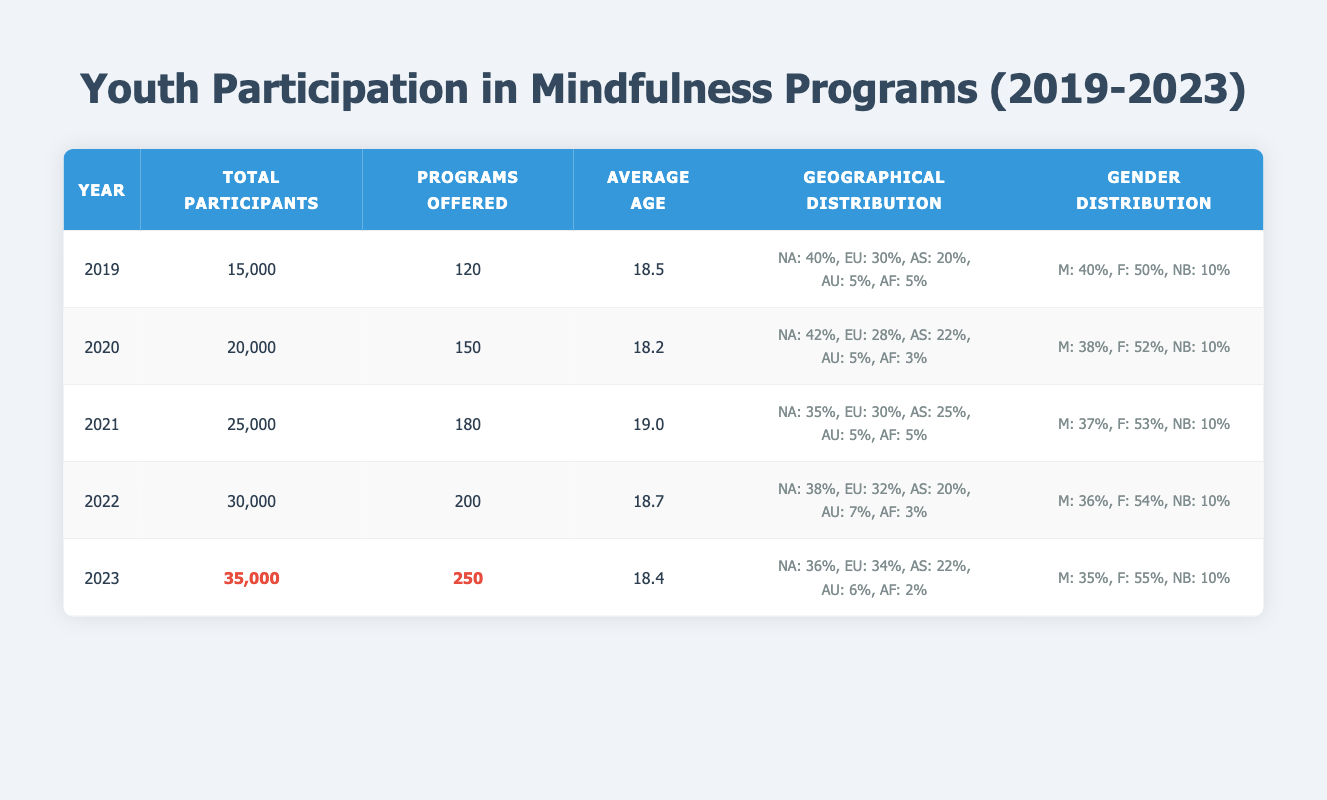What year had the highest number of total participants? By looking at the table, we can see that the total participants increased each year from 2019 to 2023. At a glance, 2023 has the highest value, which is 35000.
Answer: 2023 What was the average age of participants in 2021? The table lists the average age for each year. For the year 2021, the specific figure given is 19.0.
Answer: 19.0 In which year was the geographical distribution of participants from North America the lowest? Checking the North America percentages across the years, 2019 had 40%, following years showed higher numbers until 2021, which was the lowest at 35% in 2021.
Answer: 2021 How many more programs were offered in 2023 compared to 2019? To find the difference, subtract the number of programs offered in 2019 (120) from the number in 2023 (250): 250 - 120 = 130.
Answer: 130 Is there an increase in female participants from 2019 to 2023? By comparing the gender distribution of females, in 2019 it was 50%, and in 2023 it is 55%. This indicates an increase.
Answer: Yes What is the total percentage of participants from Asia in 2020 and 2022 combined? Adding the percentage of participants from Asia for 2020 (22%) and 2022 (20%) gives: 22 + 20 = 42.
Answer: 42 Between 2019 and 2023, what was the average number of total participants? First, total the participants for each year: 15000 + 20000 + 25000 + 30000 + 35000 = 125000. Then, divide this by the number of years (5): 125000 / 5 = 25000.
Answer: 25000 Which year had the highest percentage of programs offered in Europe? Reviewing the table, Europe had 32% in 2022, which is higher than other years.
Answer: 2022 What was the total participant count in 2021 and 2022? Combining the participants of both years gives: 25000 (2021) + 30000 (2022) = 55000.
Answer: 55000 